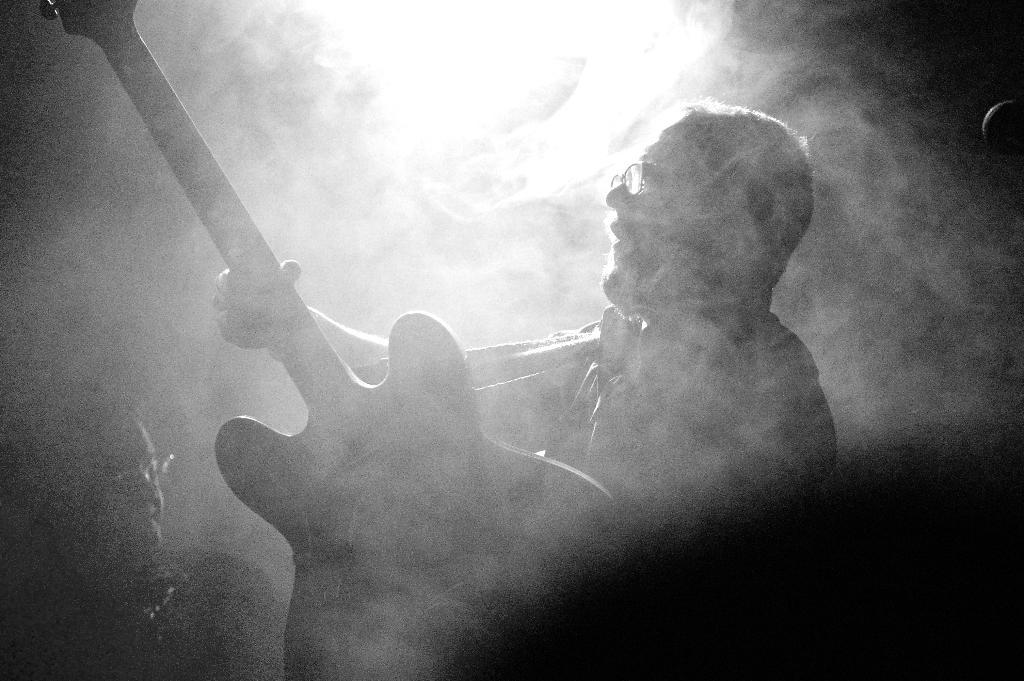What is the man in the image holding? The man is holding a guitar in the image. Can you describe the person located at the bottom left side of the image? There is a person at the bottom left side of the image, but their appearance or actions are not specified. What is the weather or visibility like in the image? There is fog at the top of the image, which may indicate low visibility or a misty environment. What is the source of light in the image? There is light at the top of the image, but its origin or purpose is not specified. What type of oatmeal is being measured by the person at the bottom left side of the image? There is no oatmeal or measuring activity present in the image. 